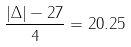Convert formula to latex. <formula><loc_0><loc_0><loc_500><loc_500>\frac { | \Delta | - 2 7 } { 4 } = 2 0 . 2 5</formula> 